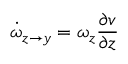Convert formula to latex. <formula><loc_0><loc_0><loc_500><loc_500>\dot { \omega } _ { z \rightarrow y } = \omega _ { z } \frac { \partial v } { \partial z }</formula> 